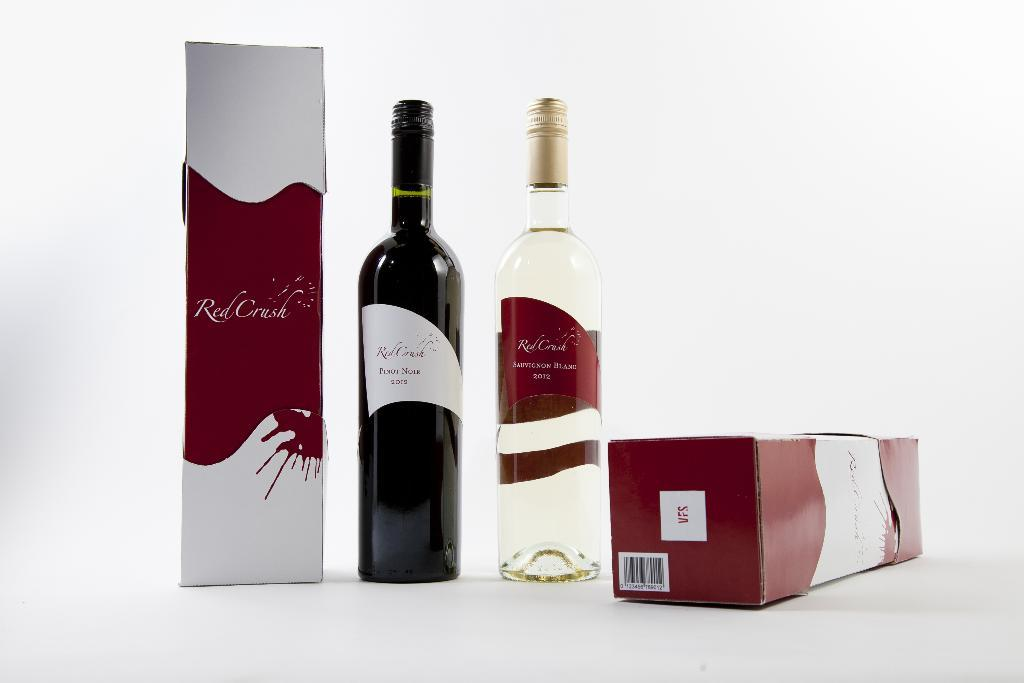<image>
Write a terse but informative summary of the picture. Bottle of wine next to a box that says Red Creek. 